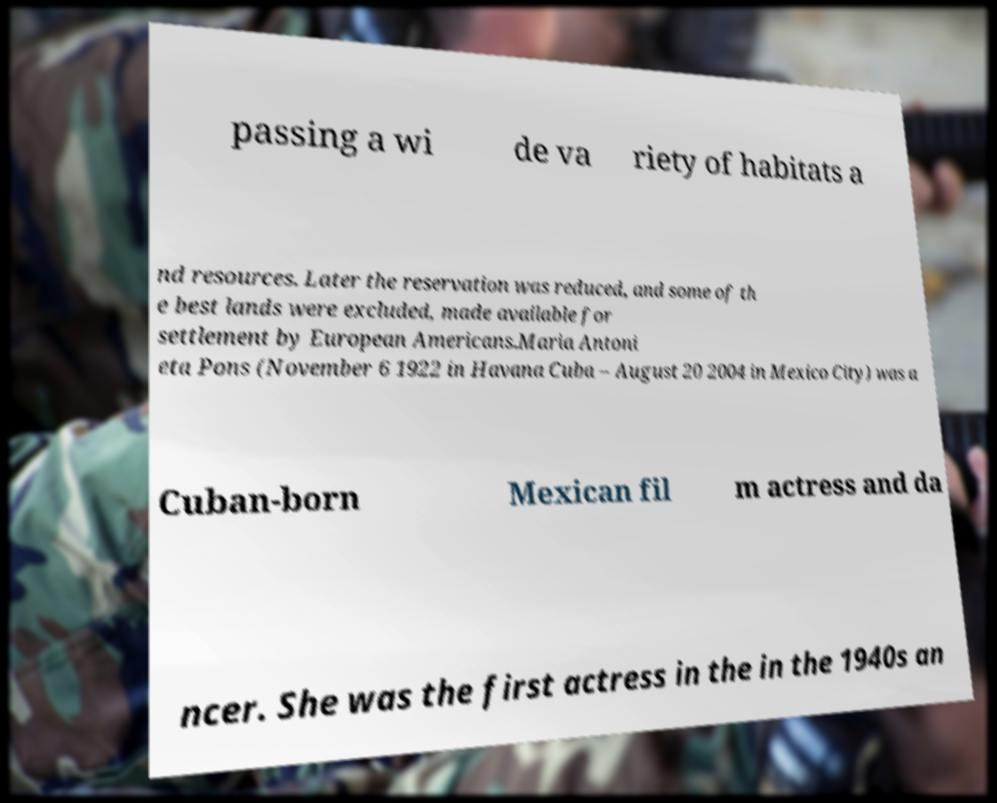Can you accurately transcribe the text from the provided image for me? passing a wi de va riety of habitats a nd resources. Later the reservation was reduced, and some of th e best lands were excluded, made available for settlement by European Americans.Maria Antoni eta Pons (November 6 1922 in Havana Cuba – August 20 2004 in Mexico City) was a Cuban-born Mexican fil m actress and da ncer. She was the first actress in the in the 1940s an 